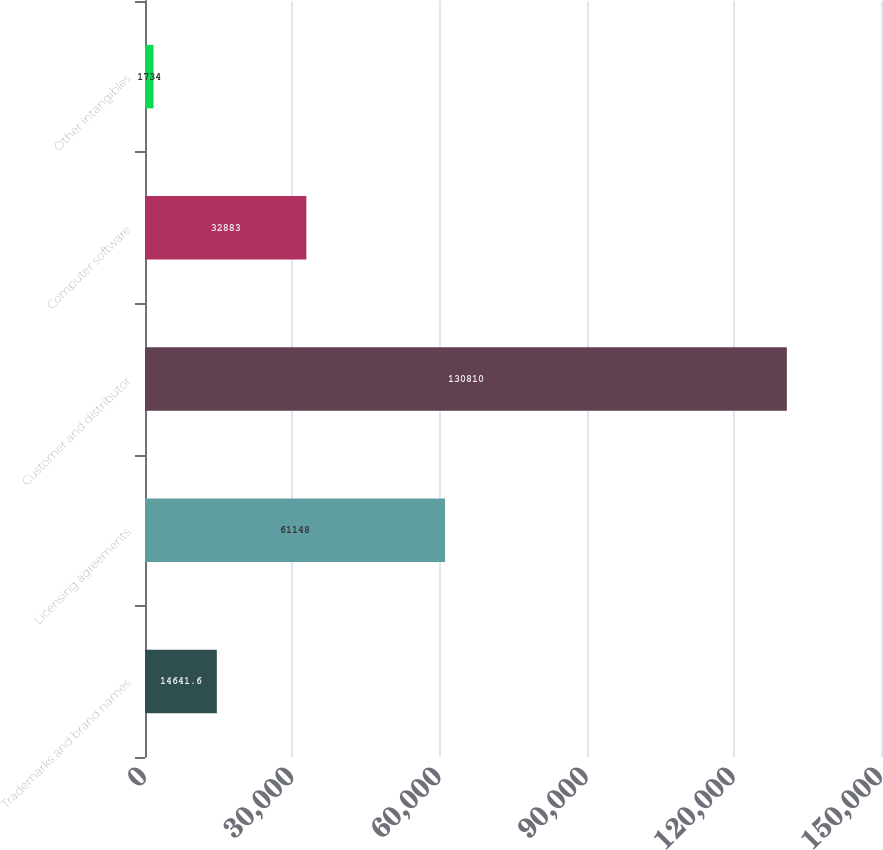<chart> <loc_0><loc_0><loc_500><loc_500><bar_chart><fcel>Trademarks and brand names<fcel>Licensing agreements<fcel>Customer and distributor<fcel>Computer software<fcel>Other intangibles<nl><fcel>14641.6<fcel>61148<fcel>130810<fcel>32883<fcel>1734<nl></chart> 